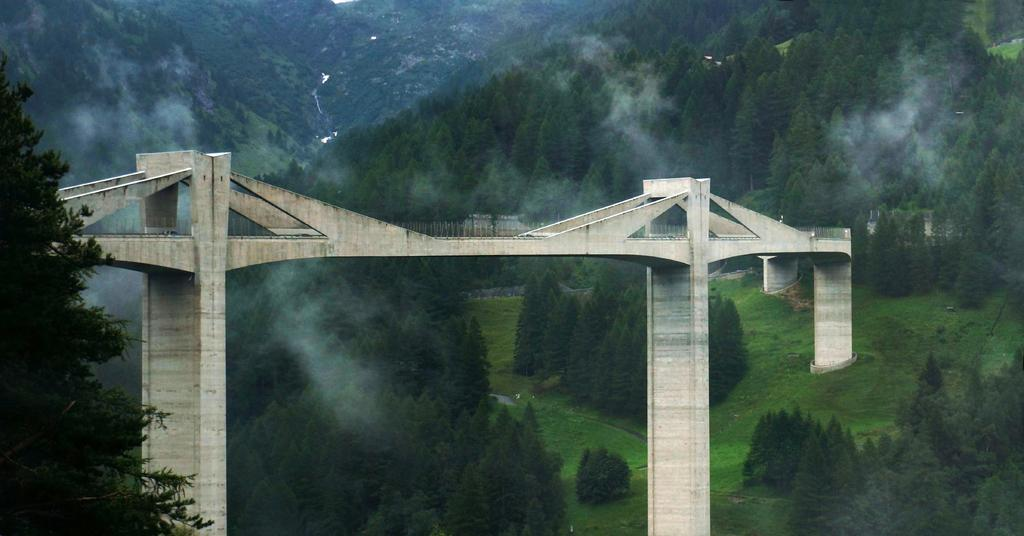What structure is present in the image? There is a bridge in the image. Where is the bridge located? The bridge is on a path. What can be seen behind the bridge? There are trees behind the bridge. What is visible in the distance behind the trees? There are hills visible in the background, and there is fog present as well. How many grapes are hanging from the bridge in the image? There are no grapes present in the image; the bridge is not a vineyard. 